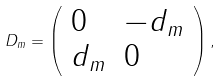Convert formula to latex. <formula><loc_0><loc_0><loc_500><loc_500>D _ { m } = \left ( \begin{array} { l l } { 0 } & { { - d _ { m } } } \\ { { d _ { m } } } & { 0 } \end{array} \right ) ,</formula> 